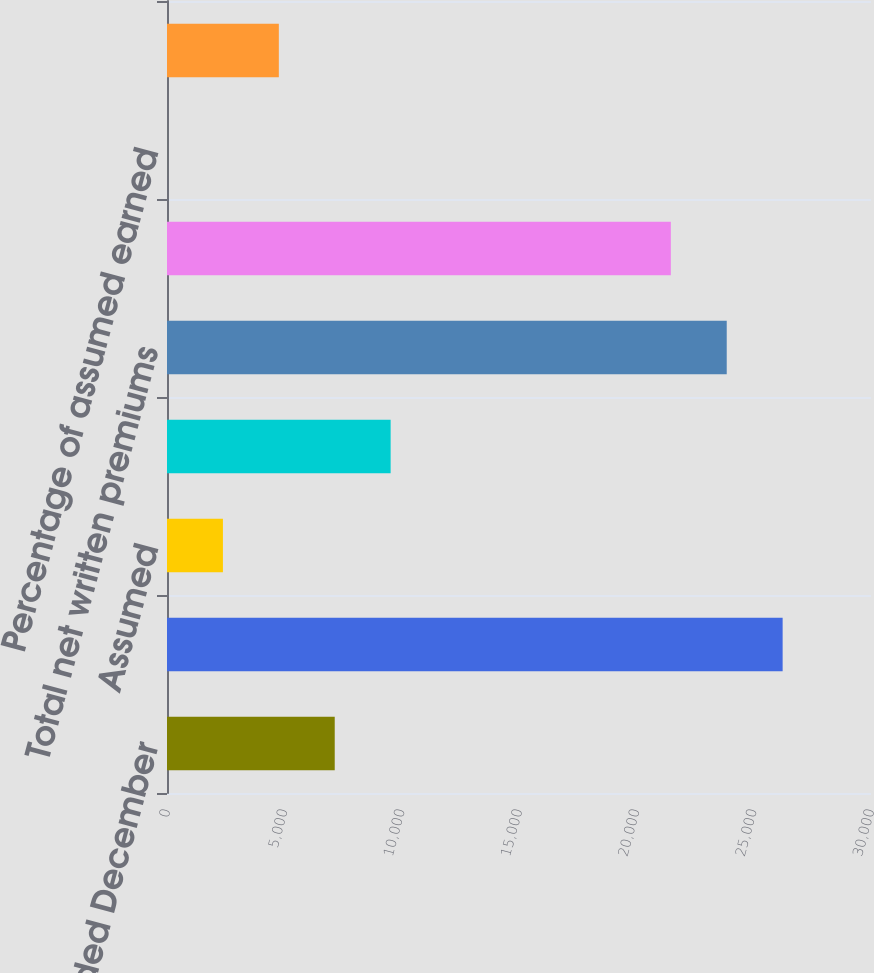Convert chart to OTSL. <chart><loc_0><loc_0><loc_500><loc_500><bar_chart><fcel>(for the year ended December<fcel>Direct<fcel>Assumed<fcel>Ceded<fcel>Total net written premiums<fcel>Total net earned premiums<fcel>Percentage of assumed earned<fcel>Ceded claims and claim<nl><fcel>7147.76<fcel>26234.6<fcel>2383.12<fcel>9530.08<fcel>23852.3<fcel>21470<fcel>0.8<fcel>4765.44<nl></chart> 